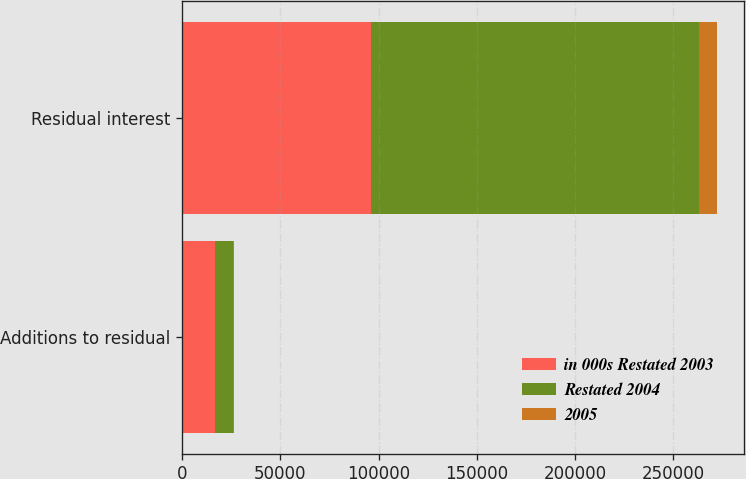Convert chart. <chart><loc_0><loc_0><loc_500><loc_500><stacked_bar_chart><ecel><fcel>Additions to residual<fcel>Residual interest<nl><fcel>in 000s Restated 2003<fcel>16914<fcel>95929<nl><fcel>Restated 2004<fcel>9007<fcel>167065<nl><fcel>2005<fcel>753<fcel>9176<nl></chart> 